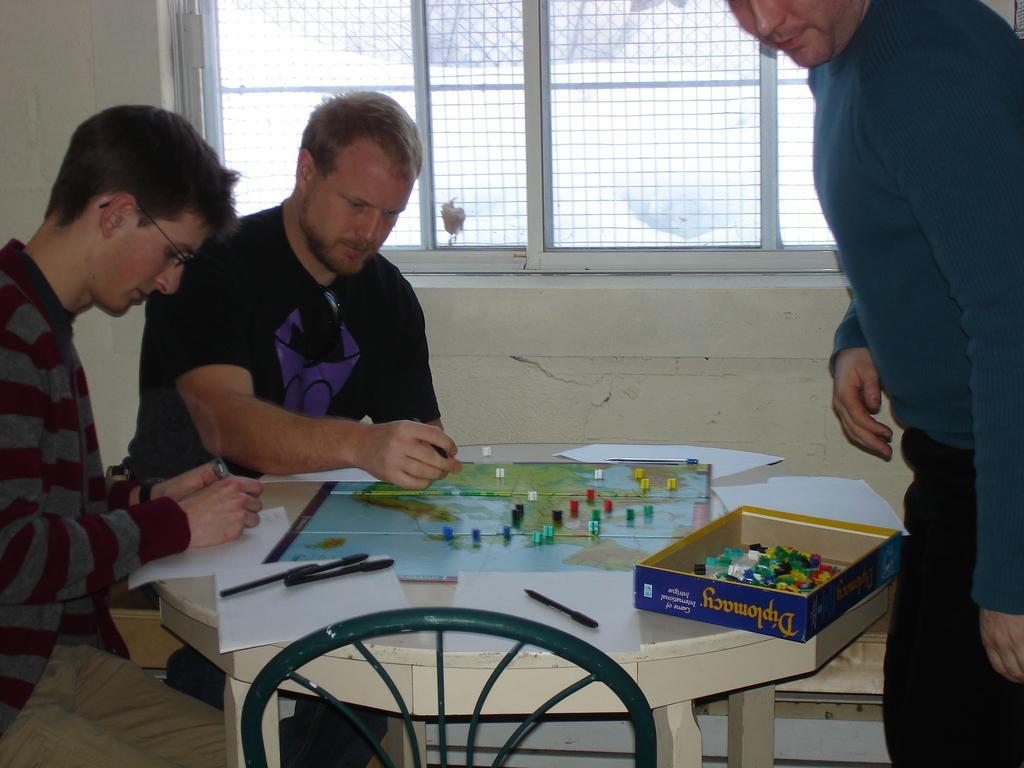In one or two sentences, can you explain what this image depicts? There are two persons sitting in the left and there is a table in front of them which has papers,pens,a board and some dices on it and there is other person standing in the right corner. 